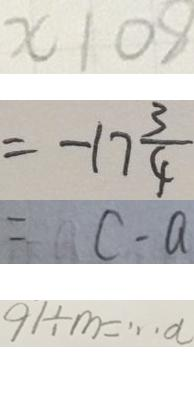<formula> <loc_0><loc_0><loc_500><loc_500>x 1 0 8 
 = - 1 7 \frac { 3 } { 4 } 
 = c - a 
 9 1 \div m = \cdots a</formula> 